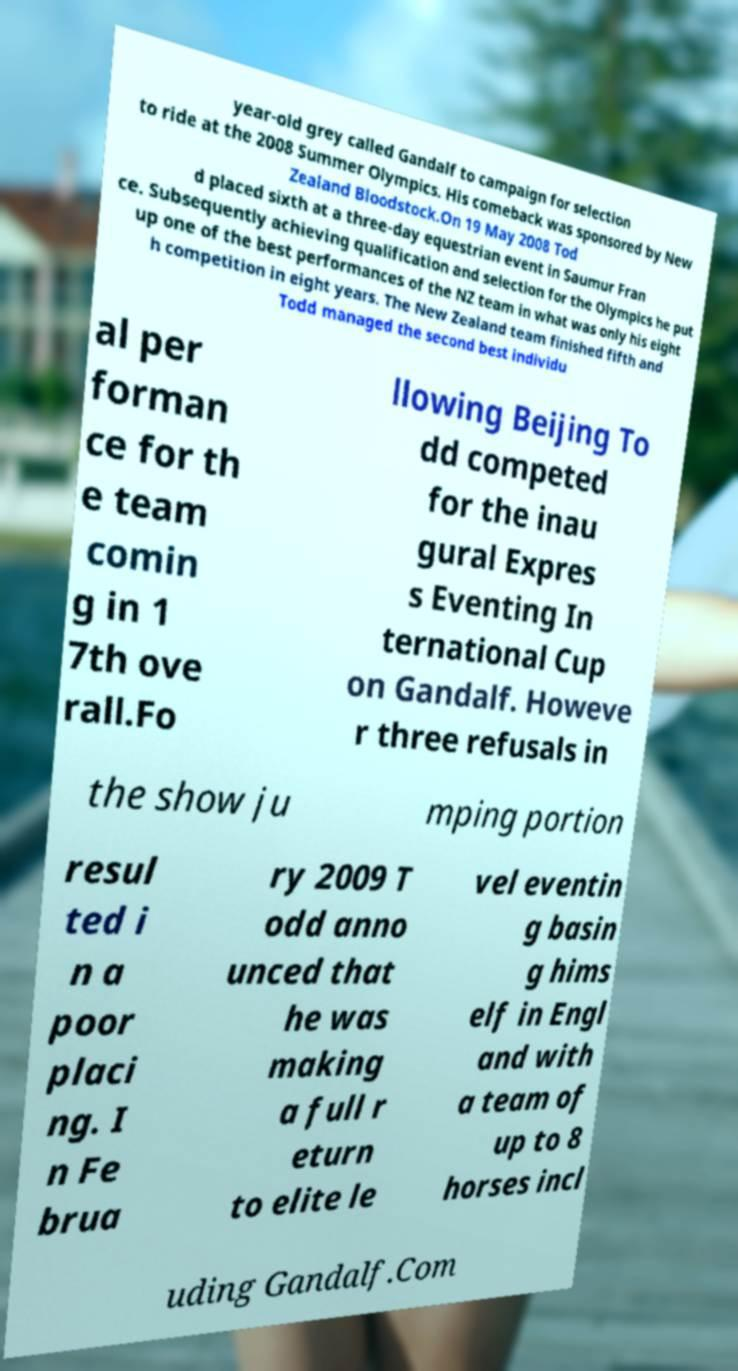There's text embedded in this image that I need extracted. Can you transcribe it verbatim? year-old grey called Gandalf to campaign for selection to ride at the 2008 Summer Olympics. His comeback was sponsored by New Zealand Bloodstock.On 19 May 2008 Tod d placed sixth at a three-day equestrian event in Saumur Fran ce. Subsequently achieving qualification and selection for the Olympics he put up one of the best performances of the NZ team in what was only his eight h competition in eight years. The New Zealand team finished fifth and Todd managed the second best individu al per forman ce for th e team comin g in 1 7th ove rall.Fo llowing Beijing To dd competed for the inau gural Expres s Eventing In ternational Cup on Gandalf. Howeve r three refusals in the show ju mping portion resul ted i n a poor placi ng. I n Fe brua ry 2009 T odd anno unced that he was making a full r eturn to elite le vel eventin g basin g hims elf in Engl and with a team of up to 8 horses incl uding Gandalf.Com 